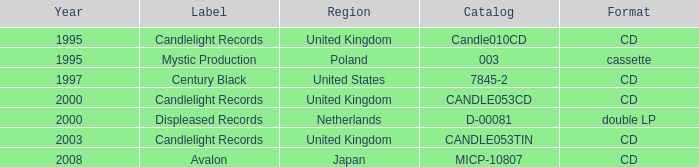What was the Candlelight Records Catalog of Candle053tin format? CD. 